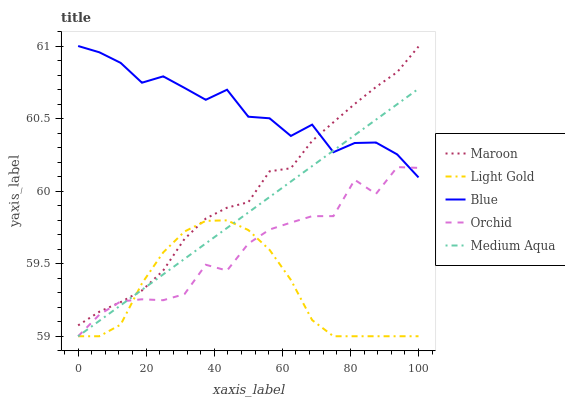Does Light Gold have the minimum area under the curve?
Answer yes or no. Yes. Does Blue have the maximum area under the curve?
Answer yes or no. Yes. Does Medium Aqua have the minimum area under the curve?
Answer yes or no. No. Does Medium Aqua have the maximum area under the curve?
Answer yes or no. No. Is Medium Aqua the smoothest?
Answer yes or no. Yes. Is Orchid the roughest?
Answer yes or no. Yes. Is Light Gold the smoothest?
Answer yes or no. No. Is Light Gold the roughest?
Answer yes or no. No. Does Maroon have the lowest value?
Answer yes or no. No. Does Medium Aqua have the highest value?
Answer yes or no. No. Is Light Gold less than Blue?
Answer yes or no. Yes. Is Blue greater than Light Gold?
Answer yes or no. Yes. Does Light Gold intersect Blue?
Answer yes or no. No. 